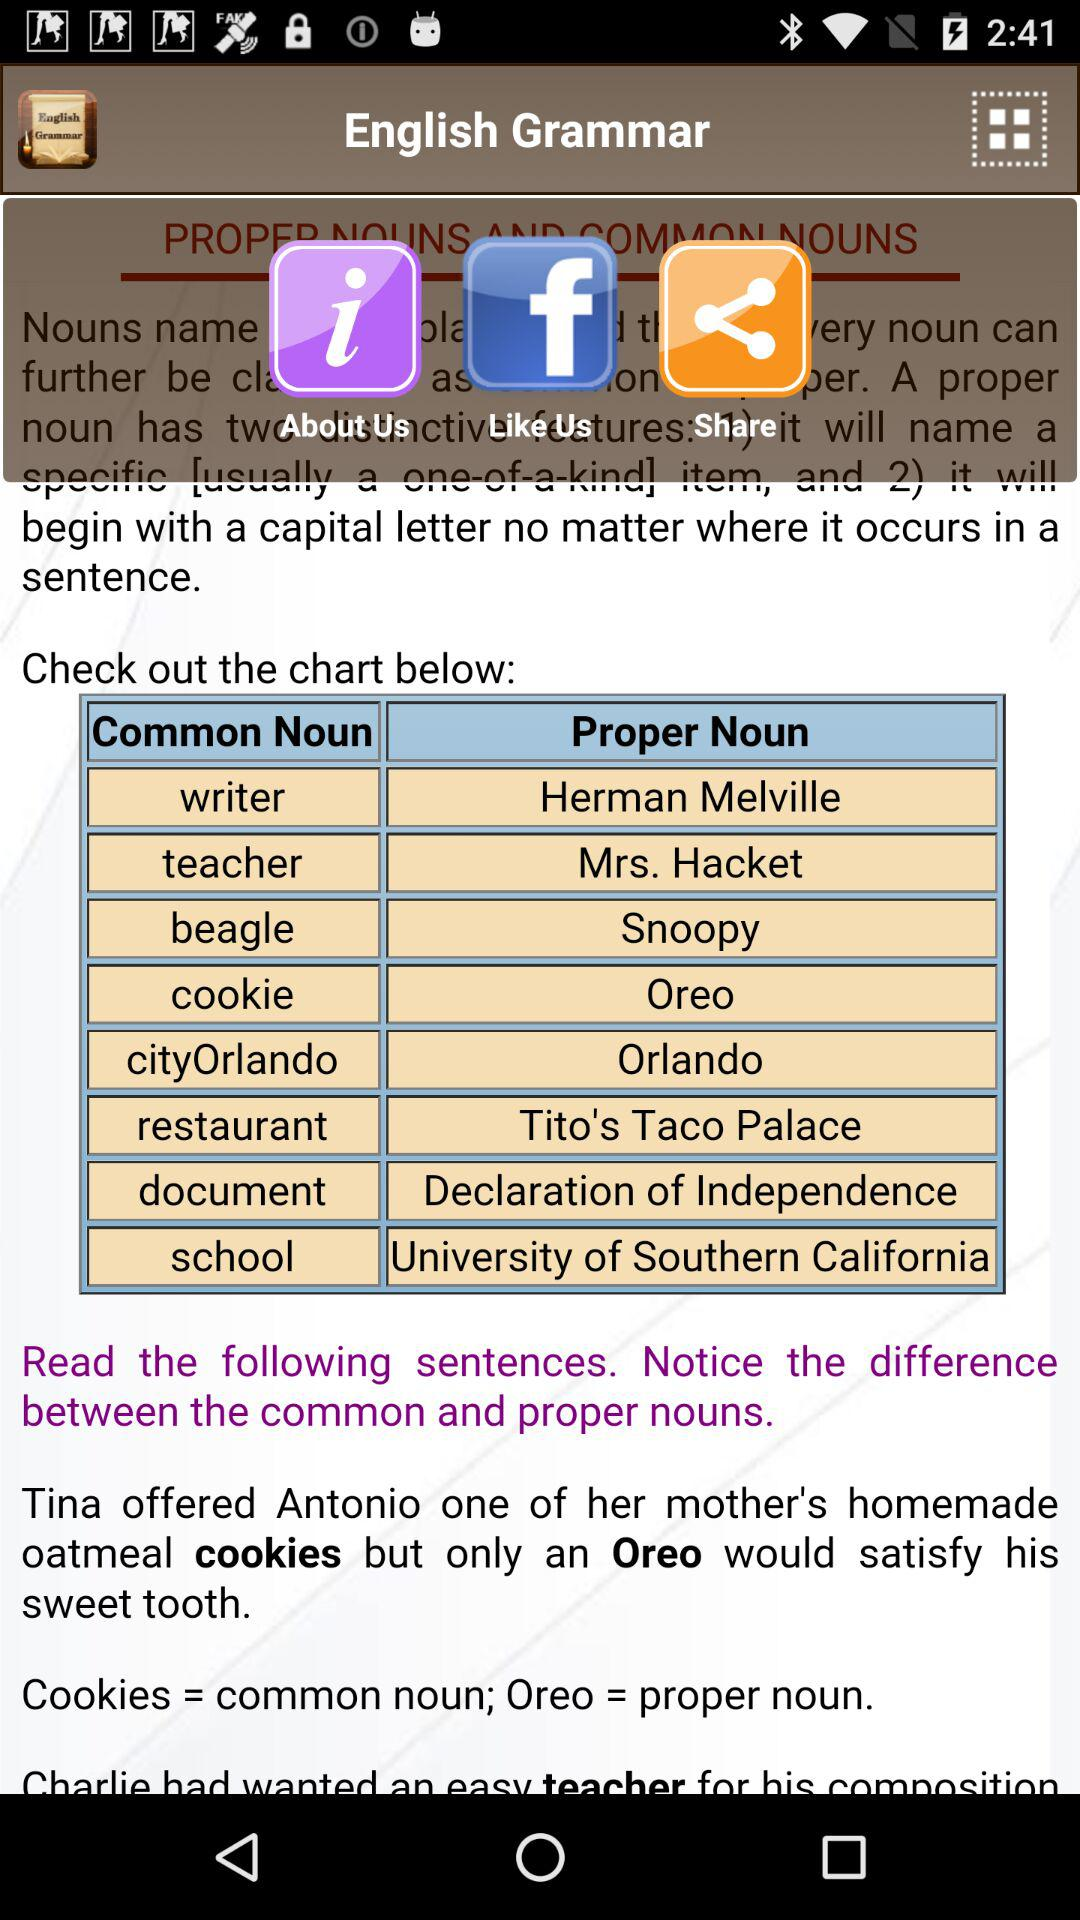What is the example in the "Proper Noun" table? The examples in the "Proper Noun" table are "Herman Melville", "Mrs. Hacket", "Snoopy", "Oreo", "Orlando", "Tito's Taco Palace", "Declaration of Independence" and "University of Southern California". 